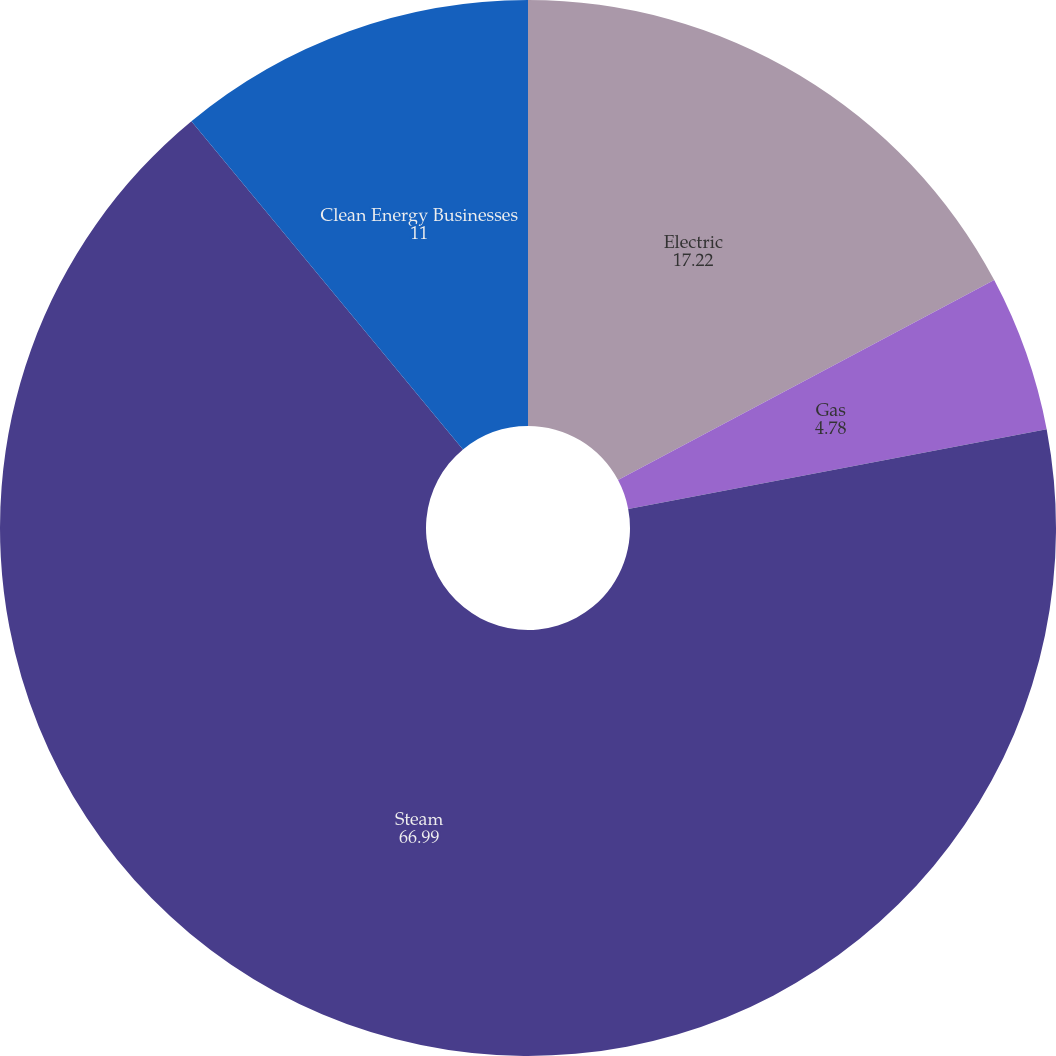Convert chart to OTSL. <chart><loc_0><loc_0><loc_500><loc_500><pie_chart><fcel>Electric<fcel>Gas<fcel>Steam<fcel>Clean Energy Businesses<nl><fcel>17.22%<fcel>4.78%<fcel>66.99%<fcel>11.0%<nl></chart> 